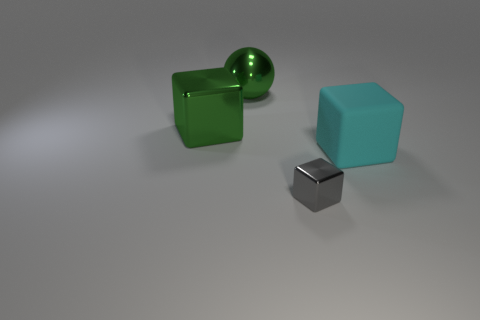What can you infer about the material properties of the objects? The shiny metal block suggests a hard, smooth texture, possibly steel or aluminum, reflecting its surroundings with high clarity. The green cube appears to be made of a less reflective material like tinted glass or polished stone, while the cyan cube might be opaque and matte, perhaps plastic or painted wood, absorbing more light than it reflects. 